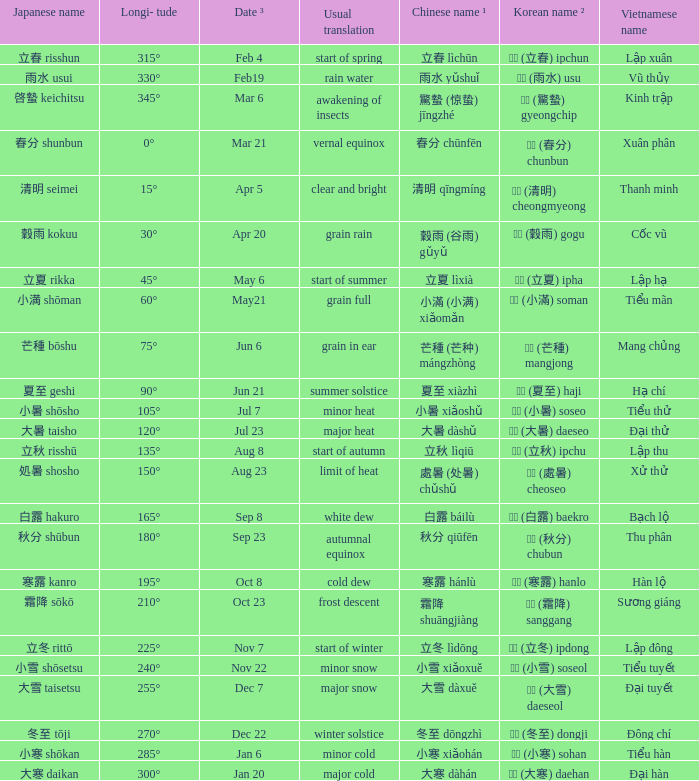When has a Korean name ² of 청명 (清明) cheongmyeong? Apr 5. 